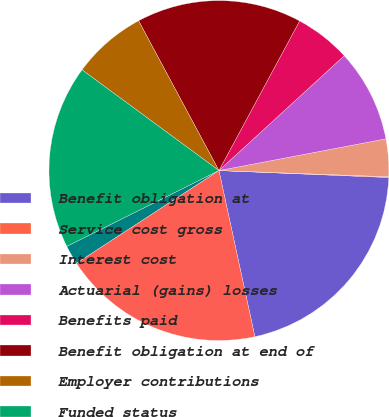Convert chart to OTSL. <chart><loc_0><loc_0><loc_500><loc_500><pie_chart><fcel>Benefit obligation at<fcel>Service cost gross<fcel>Interest cost<fcel>Actuarial (gains) losses<fcel>Benefits paid<fcel>Benefit obligation at end of<fcel>Employer contributions<fcel>Funded status<fcel>Unrecognized net actuarial<fcel>Net amount recognized<nl><fcel>20.96%<fcel>0.07%<fcel>3.57%<fcel>8.82%<fcel>5.32%<fcel>15.71%<fcel>7.07%<fcel>17.46%<fcel>1.82%<fcel>19.21%<nl></chart> 